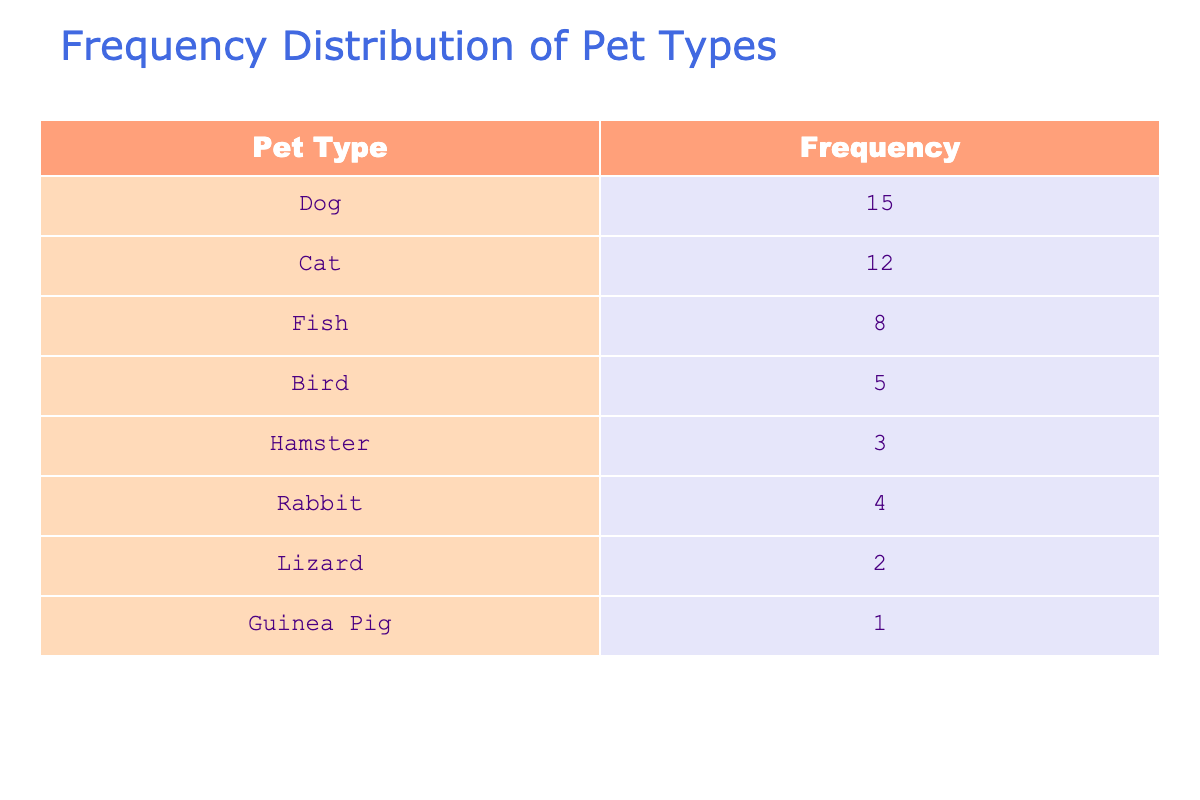What pet type has the highest frequency? From the table, the pet type with the highest frequency is "Dog," which has a frequency of 15.
Answer: Dog How many cats are owned in the neighborhood? The table shows that there are 12 cats owned in the neighborhood.
Answer: 12 What is the total number of pets owned? To find the total number of pets, we add the frequencies of all pet types: 15 (Dog) + 12 (Cat) + 8 (Fish) + 5 (Bird) + 3 (Hamster) + 4 (Rabbit) + 2 (Lizard) + 1 (Guinea Pig) = 50.
Answer: 50 Is there more than one guinea pig owned? The table shows that there is only 1 guinea pig owned in the neighborhood. Since 1 is not more than 1, the answer is no.
Answer: No What is the combined frequency of fish and birds? We can determine the combined frequency by adding the frequency of Fish (8) and Bird (5): 8 + 5 = 13.
Answer: 13 What type of pet is owned the least? Looking at the frequencies, the pet type with the lowest frequency is "Guinea Pig," which has a frequency of 1.
Answer: Guinea Pig How many more dogs are owned than rabbits? The table shows that there are 15 dogs and 4 rabbits. By subtracting the number of rabbits from the number of dogs: 15 - 4 = 11.
Answer: 11 What percentage of pets are birds? First, we calculate the total number of pets, which is 50. The frequency of birds is 5. To find the percentage, we use the formula (5/50)*100 = 10%.
Answer: 10% Are there more pets of one type than all the others combined? Adding the frequencies of all pets except for dogs (15): 12 (cat) + 8 (fish) + 5 (bird) + 3 (hamster) + 4 (rabbit) + 2 (lizard) + 1 (guinea pig) = 35. Since 15 is not greater than 35, the answer is no.
Answer: No 